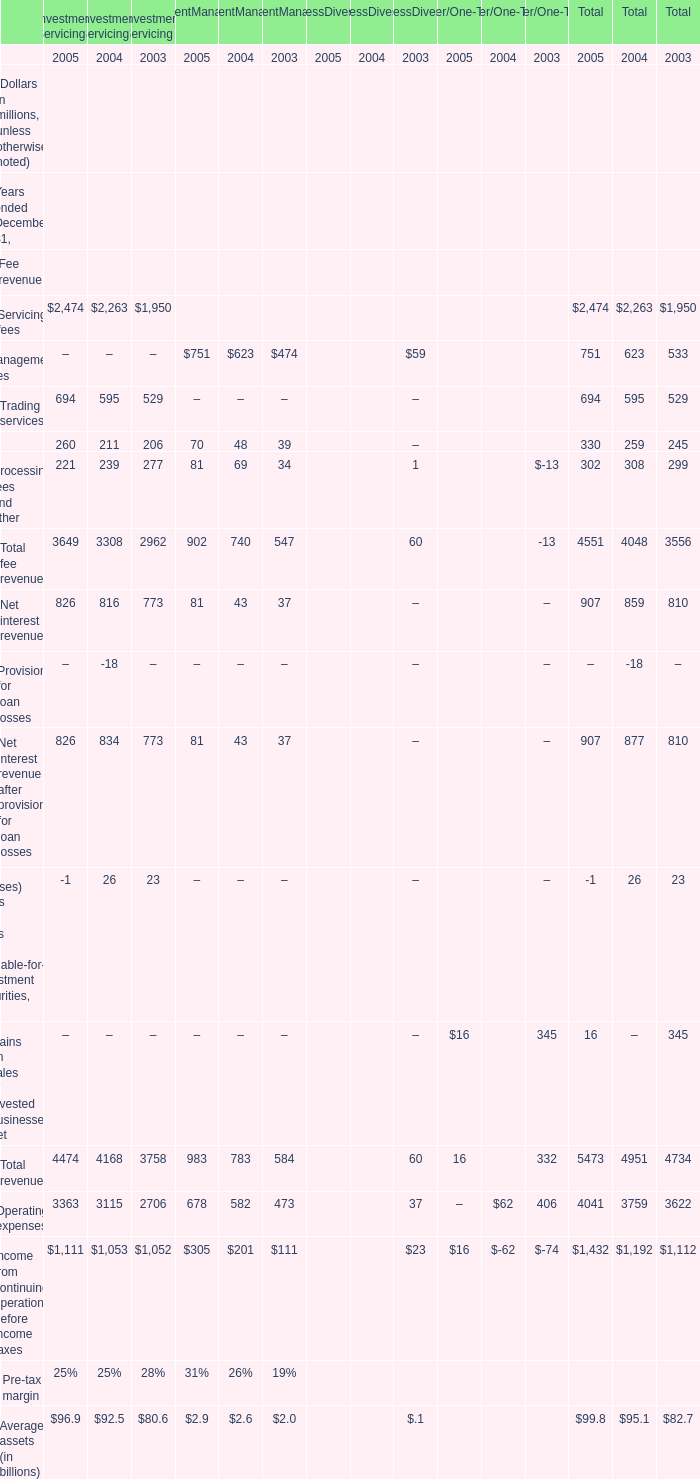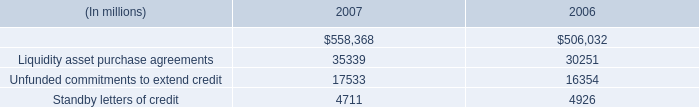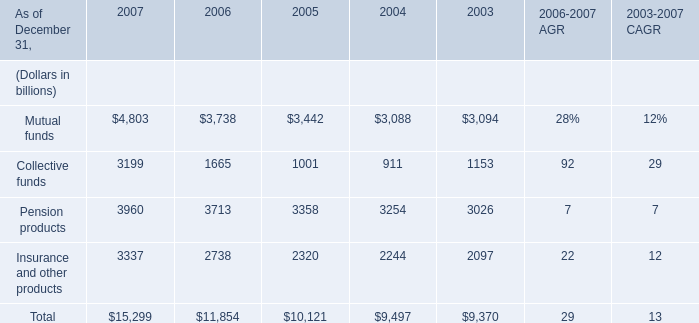What's the average of Liquidity asset purchase agreements of 2007, and Pension products of 2006 ? 
Computations: ((35339.0 + 3713.0) / 2)
Answer: 19526.0. 